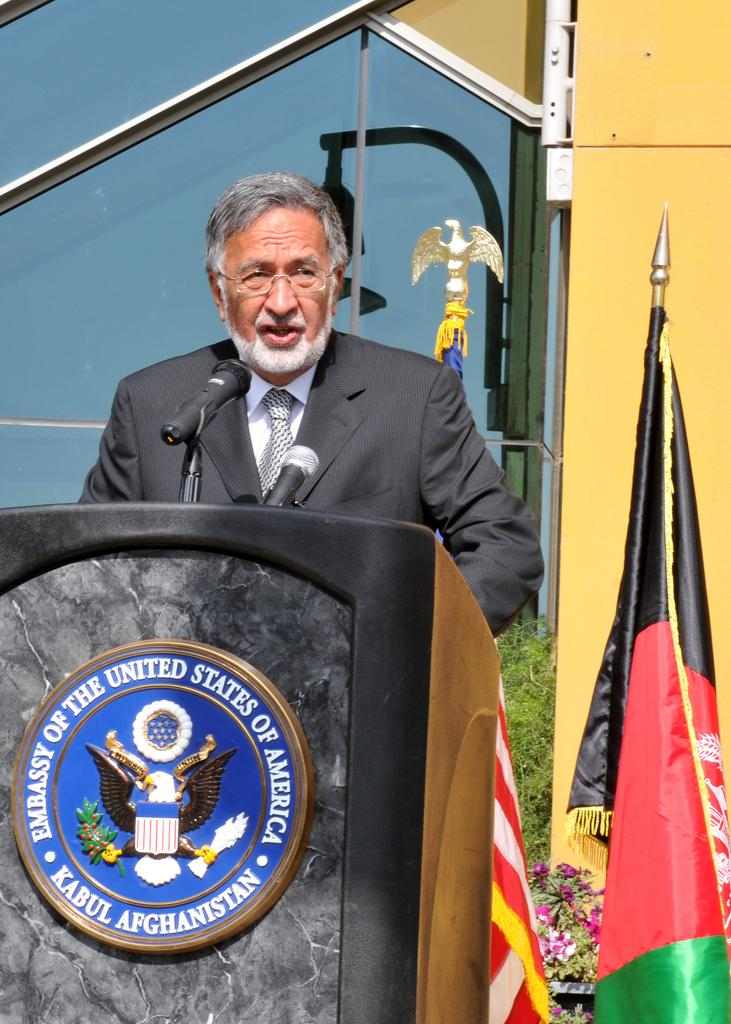Who is the main subject in the image? There is a person in the image. What is the person doing in the image? The person is standing and talking in front of a microphone. What can be seen in the background of the image? There is a flag visible in the image. How many levels can be seen in the image? There are no levels present in the image; it features a person standing and talking in front of a microphone with a flag in the background. What type of hand gesture is the person making in the image? The image does not show the person making any hand gestures; they are simply standing and talking in front of a microphone. 